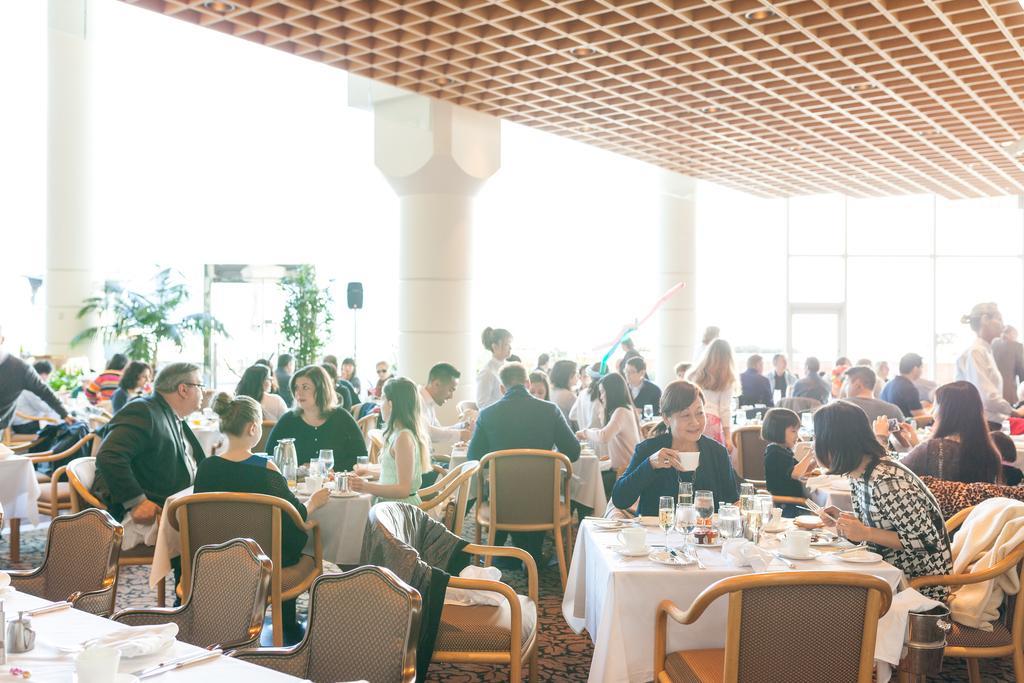Please provide a concise description of this image. In this image I can see number of people are sitting on chairs and few of them are standing. I can also see few tables and few glasses on it. In the background I can see few plants. 